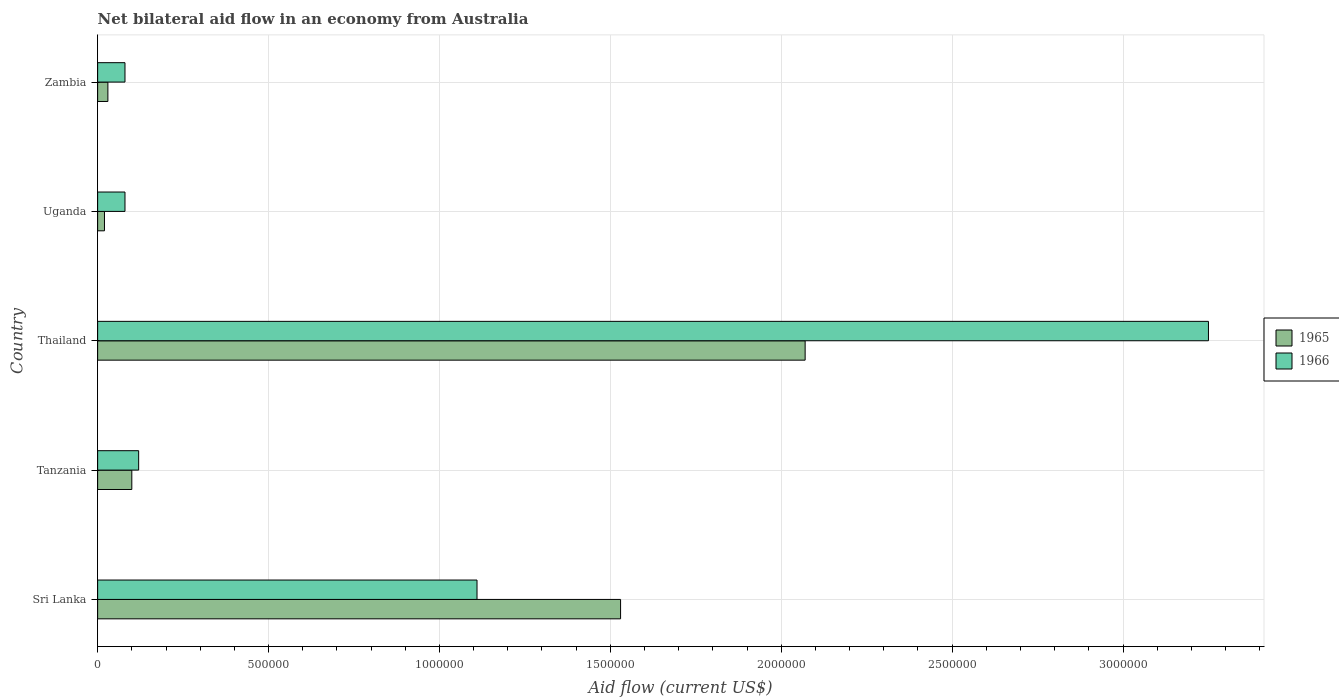How many different coloured bars are there?
Provide a short and direct response. 2. How many bars are there on the 2nd tick from the top?
Your answer should be compact. 2. How many bars are there on the 1st tick from the bottom?
Provide a succinct answer. 2. What is the label of the 2nd group of bars from the top?
Your answer should be compact. Uganda. What is the net bilateral aid flow in 1965 in Uganda?
Keep it short and to the point. 2.00e+04. Across all countries, what is the maximum net bilateral aid flow in 1966?
Make the answer very short. 3.25e+06. In which country was the net bilateral aid flow in 1966 maximum?
Make the answer very short. Thailand. In which country was the net bilateral aid flow in 1966 minimum?
Your answer should be compact. Uganda. What is the total net bilateral aid flow in 1966 in the graph?
Make the answer very short. 4.64e+06. What is the difference between the net bilateral aid flow in 1965 in Sri Lanka and the net bilateral aid flow in 1966 in Zambia?
Keep it short and to the point. 1.45e+06. What is the average net bilateral aid flow in 1966 per country?
Your response must be concise. 9.28e+05. What is the difference between the net bilateral aid flow in 1965 and net bilateral aid flow in 1966 in Tanzania?
Make the answer very short. -2.00e+04. In how many countries, is the net bilateral aid flow in 1966 greater than 400000 US$?
Provide a succinct answer. 2. What is the ratio of the net bilateral aid flow in 1965 in Sri Lanka to that in Thailand?
Keep it short and to the point. 0.74. Is the net bilateral aid flow in 1965 in Sri Lanka less than that in Zambia?
Make the answer very short. No. What is the difference between the highest and the second highest net bilateral aid flow in 1965?
Your answer should be compact. 5.40e+05. What is the difference between the highest and the lowest net bilateral aid flow in 1966?
Your response must be concise. 3.17e+06. What does the 1st bar from the top in Uganda represents?
Make the answer very short. 1966. What does the 2nd bar from the bottom in Uganda represents?
Offer a terse response. 1966. How many bars are there?
Provide a succinct answer. 10. Are all the bars in the graph horizontal?
Your answer should be compact. Yes. How many countries are there in the graph?
Your response must be concise. 5. Are the values on the major ticks of X-axis written in scientific E-notation?
Your answer should be compact. No. Where does the legend appear in the graph?
Offer a very short reply. Center right. How are the legend labels stacked?
Keep it short and to the point. Vertical. What is the title of the graph?
Keep it short and to the point. Net bilateral aid flow in an economy from Australia. What is the label or title of the Y-axis?
Your response must be concise. Country. What is the Aid flow (current US$) in 1965 in Sri Lanka?
Your response must be concise. 1.53e+06. What is the Aid flow (current US$) in 1966 in Sri Lanka?
Offer a terse response. 1.11e+06. What is the Aid flow (current US$) of 1965 in Tanzania?
Provide a short and direct response. 1.00e+05. What is the Aid flow (current US$) in 1966 in Tanzania?
Provide a succinct answer. 1.20e+05. What is the Aid flow (current US$) of 1965 in Thailand?
Ensure brevity in your answer.  2.07e+06. What is the Aid flow (current US$) of 1966 in Thailand?
Offer a terse response. 3.25e+06. What is the Aid flow (current US$) of 1965 in Uganda?
Provide a succinct answer. 2.00e+04. What is the Aid flow (current US$) in 1965 in Zambia?
Your response must be concise. 3.00e+04. Across all countries, what is the maximum Aid flow (current US$) of 1965?
Your response must be concise. 2.07e+06. Across all countries, what is the maximum Aid flow (current US$) in 1966?
Your answer should be very brief. 3.25e+06. What is the total Aid flow (current US$) in 1965 in the graph?
Give a very brief answer. 3.75e+06. What is the total Aid flow (current US$) in 1966 in the graph?
Keep it short and to the point. 4.64e+06. What is the difference between the Aid flow (current US$) of 1965 in Sri Lanka and that in Tanzania?
Your answer should be very brief. 1.43e+06. What is the difference between the Aid flow (current US$) of 1966 in Sri Lanka and that in Tanzania?
Make the answer very short. 9.90e+05. What is the difference between the Aid flow (current US$) in 1965 in Sri Lanka and that in Thailand?
Give a very brief answer. -5.40e+05. What is the difference between the Aid flow (current US$) of 1966 in Sri Lanka and that in Thailand?
Provide a succinct answer. -2.14e+06. What is the difference between the Aid flow (current US$) in 1965 in Sri Lanka and that in Uganda?
Provide a succinct answer. 1.51e+06. What is the difference between the Aid flow (current US$) of 1966 in Sri Lanka and that in Uganda?
Offer a very short reply. 1.03e+06. What is the difference between the Aid flow (current US$) of 1965 in Sri Lanka and that in Zambia?
Your answer should be compact. 1.50e+06. What is the difference between the Aid flow (current US$) of 1966 in Sri Lanka and that in Zambia?
Make the answer very short. 1.03e+06. What is the difference between the Aid flow (current US$) of 1965 in Tanzania and that in Thailand?
Provide a short and direct response. -1.97e+06. What is the difference between the Aid flow (current US$) of 1966 in Tanzania and that in Thailand?
Provide a short and direct response. -3.13e+06. What is the difference between the Aid flow (current US$) in 1965 in Tanzania and that in Zambia?
Ensure brevity in your answer.  7.00e+04. What is the difference between the Aid flow (current US$) in 1965 in Thailand and that in Uganda?
Give a very brief answer. 2.05e+06. What is the difference between the Aid flow (current US$) in 1966 in Thailand and that in Uganda?
Keep it short and to the point. 3.17e+06. What is the difference between the Aid flow (current US$) in 1965 in Thailand and that in Zambia?
Keep it short and to the point. 2.04e+06. What is the difference between the Aid flow (current US$) of 1966 in Thailand and that in Zambia?
Provide a short and direct response. 3.17e+06. What is the difference between the Aid flow (current US$) of 1966 in Uganda and that in Zambia?
Keep it short and to the point. 0. What is the difference between the Aid flow (current US$) in 1965 in Sri Lanka and the Aid flow (current US$) in 1966 in Tanzania?
Offer a very short reply. 1.41e+06. What is the difference between the Aid flow (current US$) in 1965 in Sri Lanka and the Aid flow (current US$) in 1966 in Thailand?
Offer a terse response. -1.72e+06. What is the difference between the Aid flow (current US$) of 1965 in Sri Lanka and the Aid flow (current US$) of 1966 in Uganda?
Provide a short and direct response. 1.45e+06. What is the difference between the Aid flow (current US$) of 1965 in Sri Lanka and the Aid flow (current US$) of 1966 in Zambia?
Keep it short and to the point. 1.45e+06. What is the difference between the Aid flow (current US$) of 1965 in Tanzania and the Aid flow (current US$) of 1966 in Thailand?
Offer a very short reply. -3.15e+06. What is the difference between the Aid flow (current US$) in 1965 in Tanzania and the Aid flow (current US$) in 1966 in Uganda?
Give a very brief answer. 2.00e+04. What is the difference between the Aid flow (current US$) in 1965 in Thailand and the Aid flow (current US$) in 1966 in Uganda?
Make the answer very short. 1.99e+06. What is the difference between the Aid flow (current US$) of 1965 in Thailand and the Aid flow (current US$) of 1966 in Zambia?
Your response must be concise. 1.99e+06. What is the difference between the Aid flow (current US$) of 1965 in Uganda and the Aid flow (current US$) of 1966 in Zambia?
Ensure brevity in your answer.  -6.00e+04. What is the average Aid flow (current US$) in 1965 per country?
Your answer should be compact. 7.50e+05. What is the average Aid flow (current US$) in 1966 per country?
Offer a terse response. 9.28e+05. What is the difference between the Aid flow (current US$) of 1965 and Aid flow (current US$) of 1966 in Sri Lanka?
Ensure brevity in your answer.  4.20e+05. What is the difference between the Aid flow (current US$) in 1965 and Aid flow (current US$) in 1966 in Thailand?
Give a very brief answer. -1.18e+06. What is the difference between the Aid flow (current US$) of 1965 and Aid flow (current US$) of 1966 in Uganda?
Make the answer very short. -6.00e+04. What is the ratio of the Aid flow (current US$) of 1965 in Sri Lanka to that in Tanzania?
Your answer should be compact. 15.3. What is the ratio of the Aid flow (current US$) of 1966 in Sri Lanka to that in Tanzania?
Your answer should be compact. 9.25. What is the ratio of the Aid flow (current US$) of 1965 in Sri Lanka to that in Thailand?
Give a very brief answer. 0.74. What is the ratio of the Aid flow (current US$) in 1966 in Sri Lanka to that in Thailand?
Your answer should be compact. 0.34. What is the ratio of the Aid flow (current US$) in 1965 in Sri Lanka to that in Uganda?
Give a very brief answer. 76.5. What is the ratio of the Aid flow (current US$) in 1966 in Sri Lanka to that in Uganda?
Make the answer very short. 13.88. What is the ratio of the Aid flow (current US$) in 1966 in Sri Lanka to that in Zambia?
Provide a succinct answer. 13.88. What is the ratio of the Aid flow (current US$) in 1965 in Tanzania to that in Thailand?
Your answer should be very brief. 0.05. What is the ratio of the Aid flow (current US$) in 1966 in Tanzania to that in Thailand?
Your response must be concise. 0.04. What is the ratio of the Aid flow (current US$) in 1966 in Tanzania to that in Zambia?
Keep it short and to the point. 1.5. What is the ratio of the Aid flow (current US$) in 1965 in Thailand to that in Uganda?
Your answer should be very brief. 103.5. What is the ratio of the Aid flow (current US$) of 1966 in Thailand to that in Uganda?
Keep it short and to the point. 40.62. What is the ratio of the Aid flow (current US$) of 1966 in Thailand to that in Zambia?
Your response must be concise. 40.62. What is the difference between the highest and the second highest Aid flow (current US$) in 1965?
Offer a very short reply. 5.40e+05. What is the difference between the highest and the second highest Aid flow (current US$) of 1966?
Offer a terse response. 2.14e+06. What is the difference between the highest and the lowest Aid flow (current US$) of 1965?
Your response must be concise. 2.05e+06. What is the difference between the highest and the lowest Aid flow (current US$) in 1966?
Keep it short and to the point. 3.17e+06. 